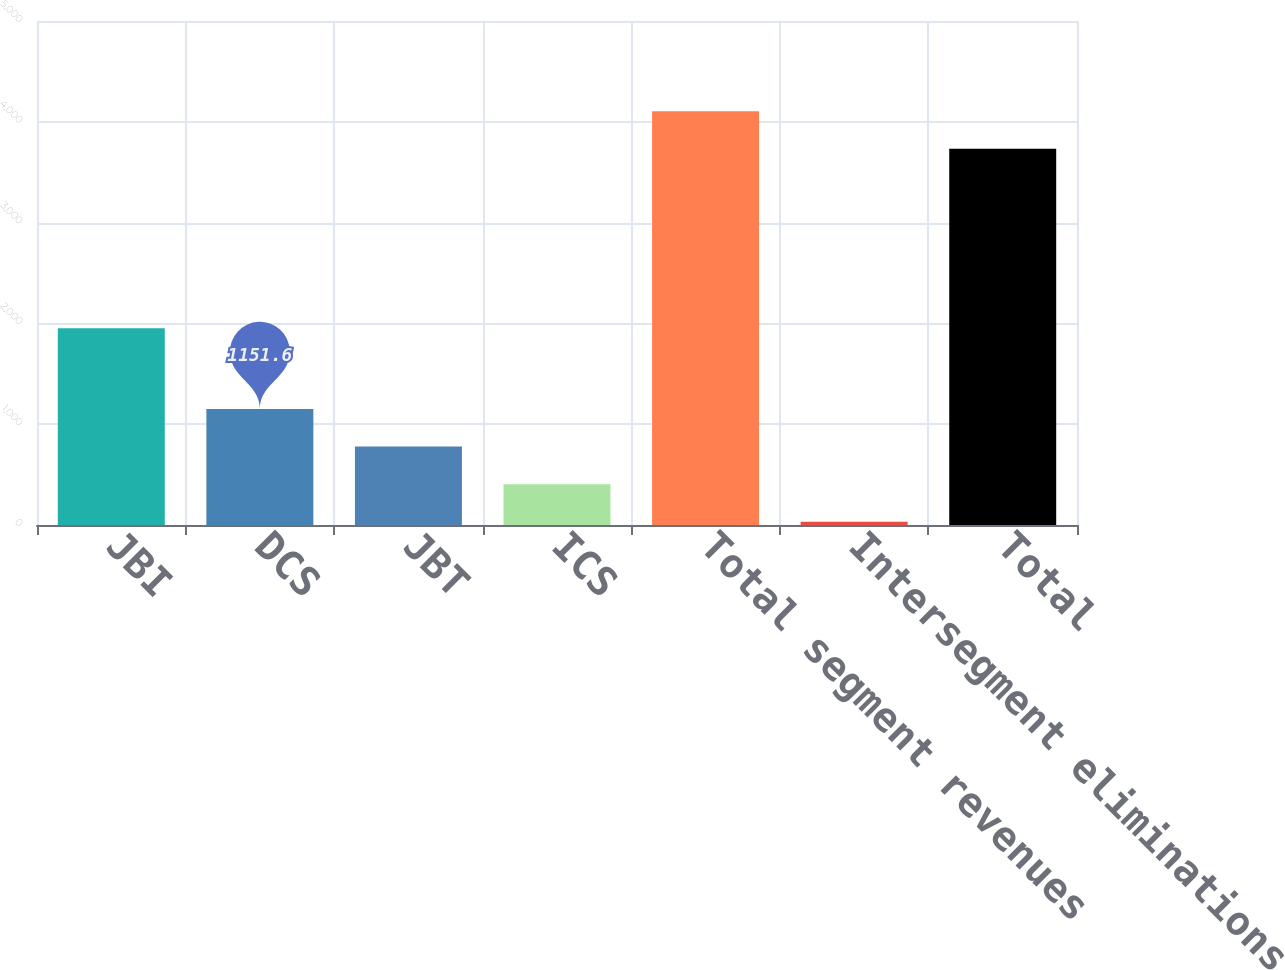Convert chart to OTSL. <chart><loc_0><loc_0><loc_500><loc_500><bar_chart><fcel>JBI<fcel>DCS<fcel>JBT<fcel>ICS<fcel>Total segment revenues<fcel>Intersegment eliminations<fcel>Total<nl><fcel>1952<fcel>1151.6<fcel>778.4<fcel>405.2<fcel>4105.2<fcel>32<fcel>3732<nl></chart> 